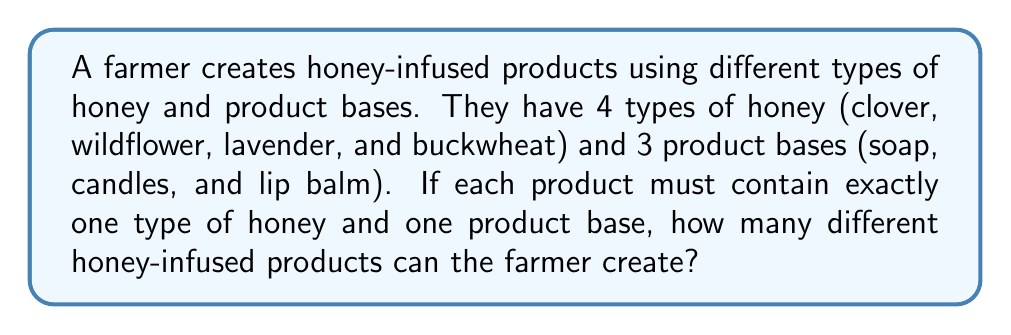Show me your answer to this math problem. To solve this problem, we can use the multiplication principle of combinatorics. Here's the step-by-step solution:

1. Identify the independent choices:
   - Choice of honey type
   - Choice of product base

2. Count the number of options for each choice:
   - Number of honey types: 4
   - Number of product bases: 3

3. Apply the multiplication principle:
   When we have independent choices, we multiply the number of options for each choice to get the total number of possible combinations.

   $$ \text{Total combinations} = \text{Number of honey types} \times \text{Number of product bases} $$

4. Plug in the values:
   $$ \text{Total combinations} = 4 \times 3 = 12 $$

Therefore, the farmer can create 12 different honey-infused products.
Answer: 12 